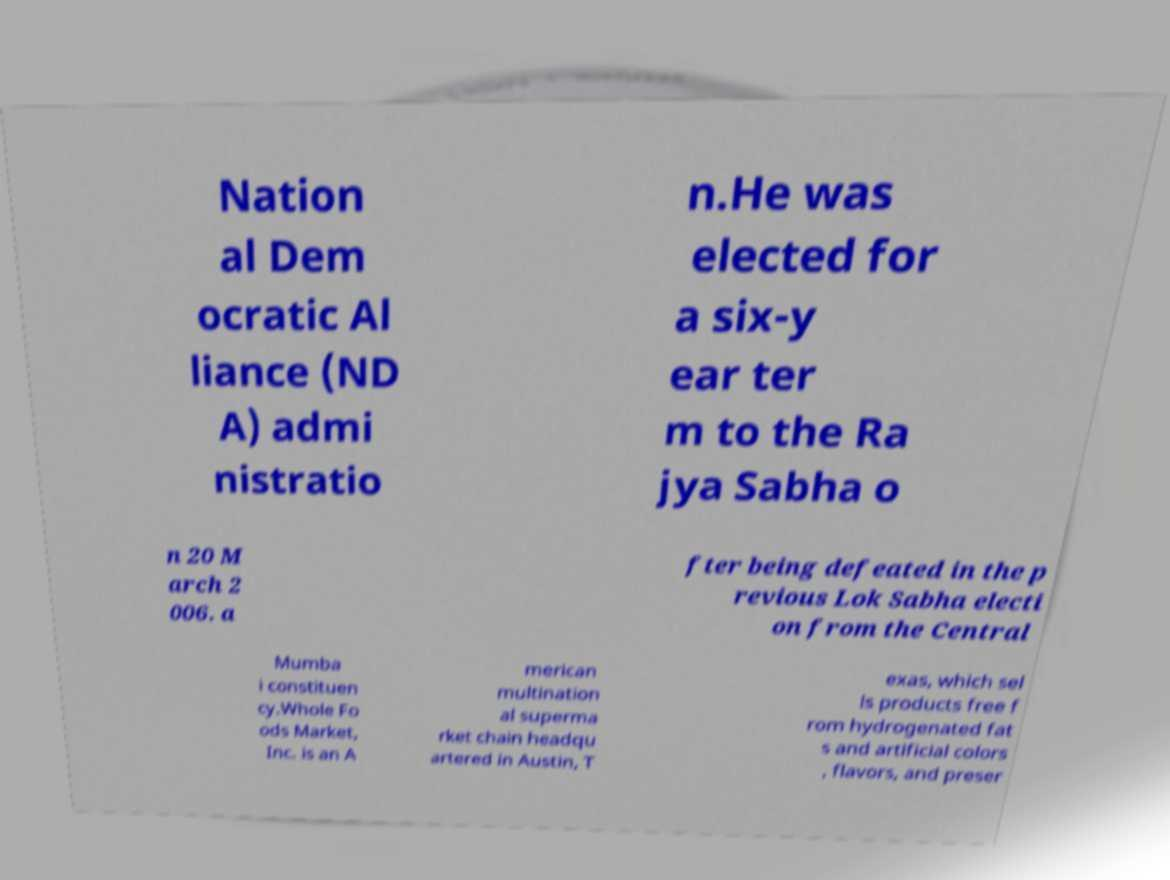Could you assist in decoding the text presented in this image and type it out clearly? Nation al Dem ocratic Al liance (ND A) admi nistratio n.He was elected for a six-y ear ter m to the Ra jya Sabha o n 20 M arch 2 006. a fter being defeated in the p revious Lok Sabha electi on from the Central Mumba i constituen cy.Whole Fo ods Market, Inc. is an A merican multination al superma rket chain headqu artered in Austin, T exas, which sel ls products free f rom hydrogenated fat s and artificial colors , flavors, and preser 